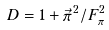<formula> <loc_0><loc_0><loc_500><loc_500>D = 1 + \vec { \pi } ^ { \, 2 } / F ^ { 2 } _ { \pi }</formula> 